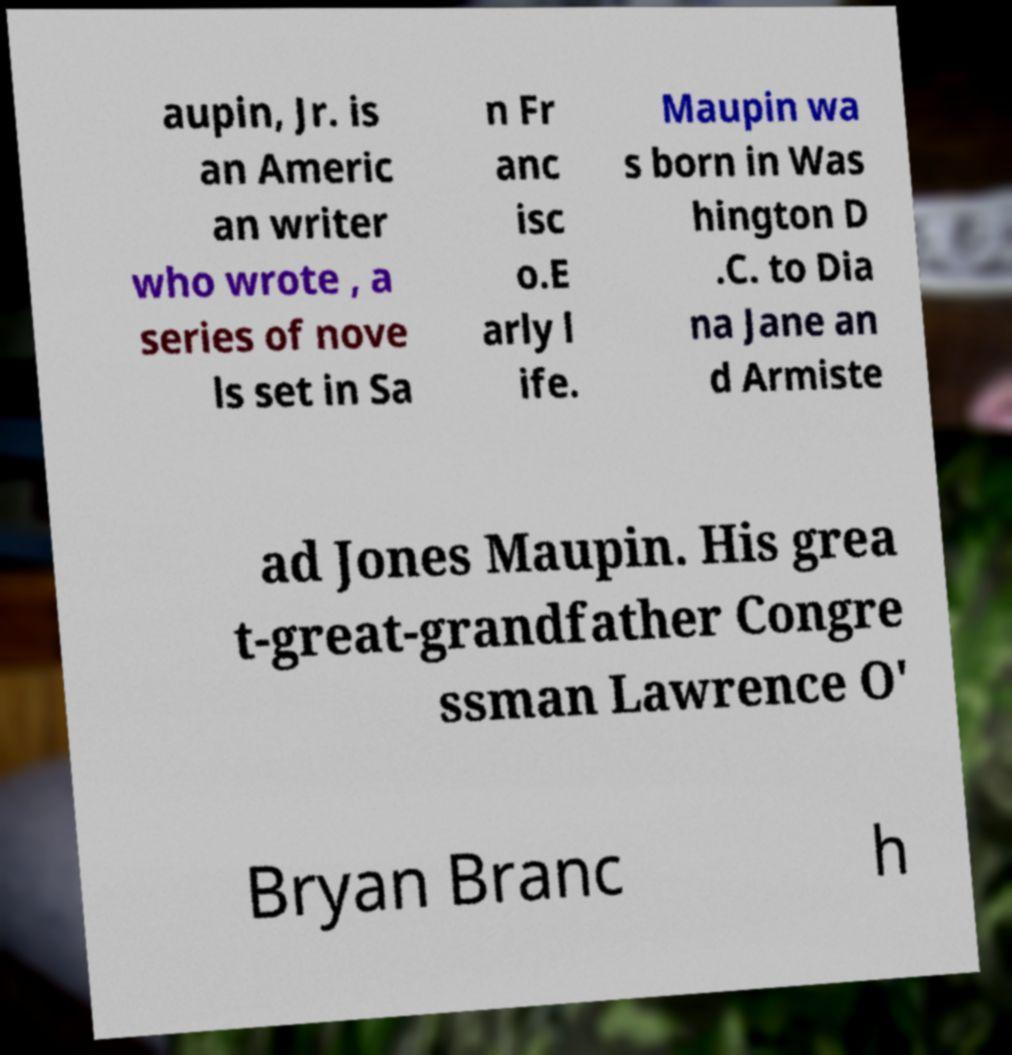Can you accurately transcribe the text from the provided image for me? aupin, Jr. is an Americ an writer who wrote , a series of nove ls set in Sa n Fr anc isc o.E arly l ife. Maupin wa s born in Was hington D .C. to Dia na Jane an d Armiste ad Jones Maupin. His grea t-great-grandfather Congre ssman Lawrence O' Bryan Branc h 